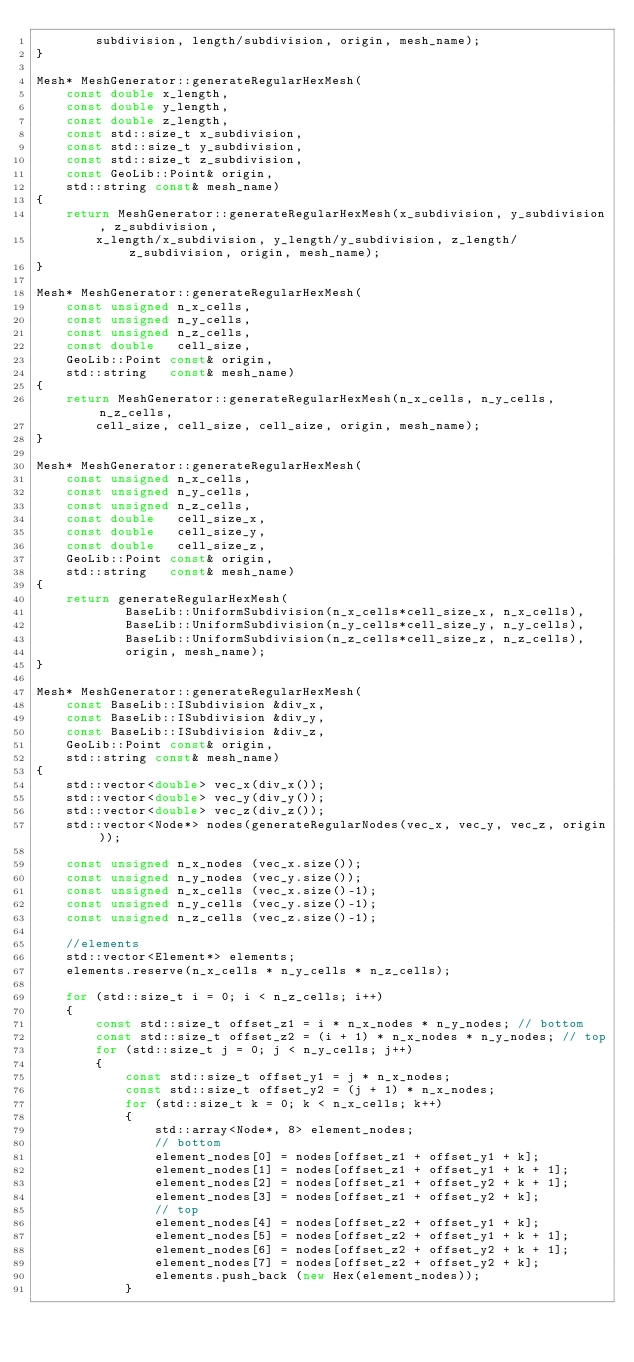Convert code to text. <code><loc_0><loc_0><loc_500><loc_500><_C++_>        subdivision, length/subdivision, origin, mesh_name);
}

Mesh* MeshGenerator::generateRegularHexMesh(
    const double x_length,
    const double y_length,
    const double z_length,
    const std::size_t x_subdivision,
    const std::size_t y_subdivision,
    const std::size_t z_subdivision,
    const GeoLib::Point& origin,
    std::string const& mesh_name)
{
    return MeshGenerator::generateRegularHexMesh(x_subdivision, y_subdivision, z_subdivision,
        x_length/x_subdivision, y_length/y_subdivision, z_length/z_subdivision, origin, mesh_name);
}

Mesh* MeshGenerator::generateRegularHexMesh(
    const unsigned n_x_cells,
    const unsigned n_y_cells,
    const unsigned n_z_cells,
    const double   cell_size,
    GeoLib::Point const& origin,
    std::string   const& mesh_name)
{
    return MeshGenerator::generateRegularHexMesh(n_x_cells, n_y_cells, n_z_cells,
        cell_size, cell_size, cell_size, origin, mesh_name);
}

Mesh* MeshGenerator::generateRegularHexMesh(
    const unsigned n_x_cells,
    const unsigned n_y_cells,
    const unsigned n_z_cells,
    const double   cell_size_x,
    const double   cell_size_y,
    const double   cell_size_z,
    GeoLib::Point const& origin,
    std::string   const& mesh_name)
{
    return generateRegularHexMesh(
            BaseLib::UniformSubdivision(n_x_cells*cell_size_x, n_x_cells),
            BaseLib::UniformSubdivision(n_y_cells*cell_size_y, n_y_cells),
            BaseLib::UniformSubdivision(n_z_cells*cell_size_z, n_z_cells),
            origin, mesh_name);
}

Mesh* MeshGenerator::generateRegularHexMesh(
    const BaseLib::ISubdivision &div_x,
    const BaseLib::ISubdivision &div_y,
    const BaseLib::ISubdivision &div_z,
    GeoLib::Point const& origin,
    std::string const& mesh_name)
{
    std::vector<double> vec_x(div_x());
    std::vector<double> vec_y(div_y());
    std::vector<double> vec_z(div_z());
    std::vector<Node*> nodes(generateRegularNodes(vec_x, vec_y, vec_z, origin));

    const unsigned n_x_nodes (vec_x.size());
    const unsigned n_y_nodes (vec_y.size());
    const unsigned n_x_cells (vec_x.size()-1);
    const unsigned n_y_cells (vec_y.size()-1);
    const unsigned n_z_cells (vec_z.size()-1);

    //elements
    std::vector<Element*> elements;
    elements.reserve(n_x_cells * n_y_cells * n_z_cells);

    for (std::size_t i = 0; i < n_z_cells; i++)
    {
        const std::size_t offset_z1 = i * n_x_nodes * n_y_nodes; // bottom
        const std::size_t offset_z2 = (i + 1) * n_x_nodes * n_y_nodes; // top
        for (std::size_t j = 0; j < n_y_cells; j++)
        {
            const std::size_t offset_y1 = j * n_x_nodes;
            const std::size_t offset_y2 = (j + 1) * n_x_nodes;
            for (std::size_t k = 0; k < n_x_cells; k++)
            {
                std::array<Node*, 8> element_nodes;
                // bottom
                element_nodes[0] = nodes[offset_z1 + offset_y1 + k];
                element_nodes[1] = nodes[offset_z1 + offset_y1 + k + 1];
                element_nodes[2] = nodes[offset_z1 + offset_y2 + k + 1];
                element_nodes[3] = nodes[offset_z1 + offset_y2 + k];
                // top
                element_nodes[4] = nodes[offset_z2 + offset_y1 + k];
                element_nodes[5] = nodes[offset_z2 + offset_y1 + k + 1];
                element_nodes[6] = nodes[offset_z2 + offset_y2 + k + 1];
                element_nodes[7] = nodes[offset_z2 + offset_y2 + k];
                elements.push_back (new Hex(element_nodes));
            }</code> 